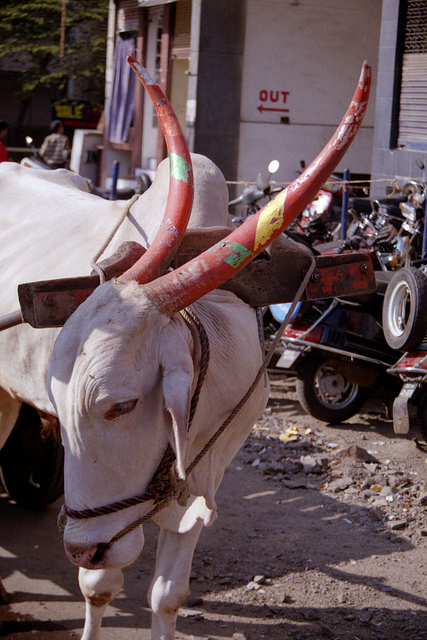Please identify all text content in this image. OUT 